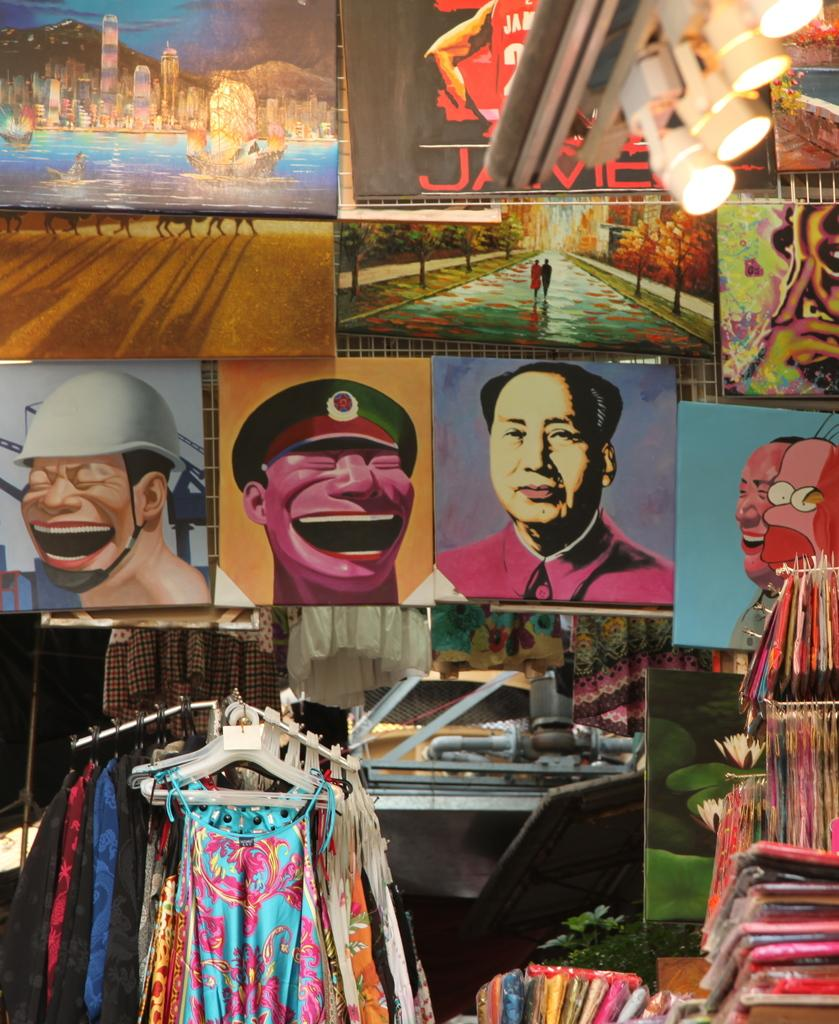What type of items can be seen in the image? There are clothes, frames, lights, and leaves in the image. Can you describe the unspecified objects in the image? Unfortunately, the provided facts do not specify the nature of the unspecified objects. What type of lighting is present in the image? There are lights in the image, but the specific type or style of lighting is not mentioned. What texture can be felt on the leaves in the image? The texture of the leaves cannot be determined from the image, as it is a visual medium and does not convey tactile information. 